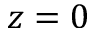<formula> <loc_0><loc_0><loc_500><loc_500>z = 0</formula> 